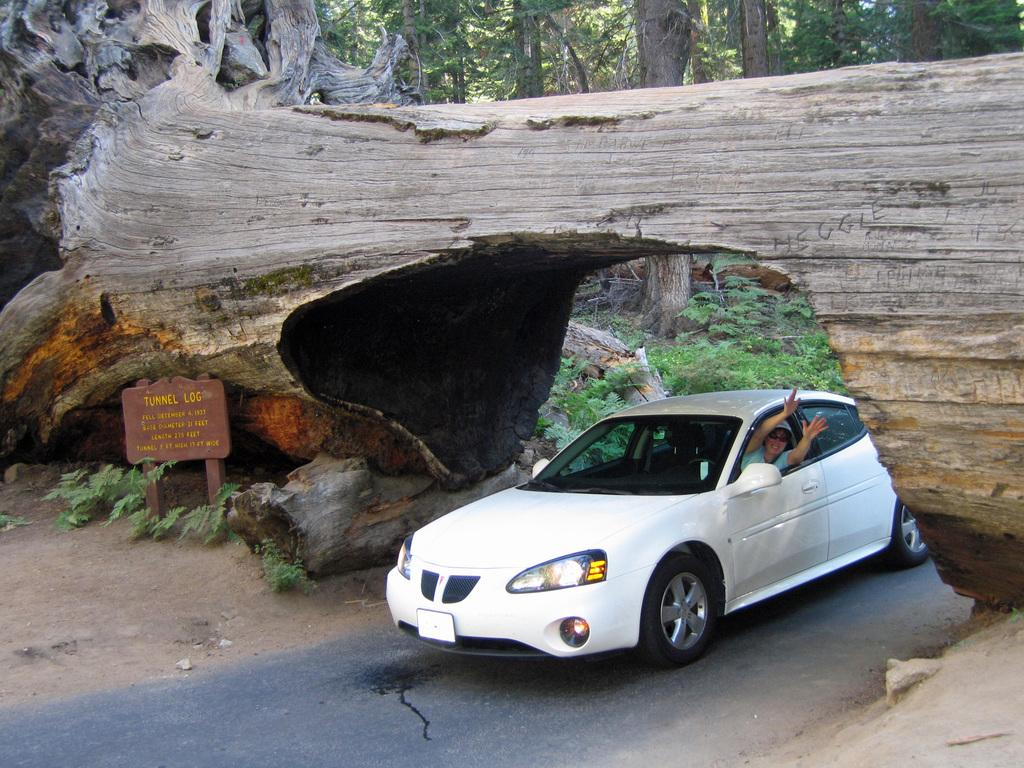What is the main subject of the image? The main subject of the image is a car. Where is the car located in the image? The car is under a tree trunk in the image. Are there any people inside the car? Yes, there are persons in the vehicle. What else can be seen in the image besides the car? There is a signboard, trees, and plants in the image. What type of cakes are being served on the airplane in the image? There is no airplane or cakes present in the image; it features a car under a tree trunk with people inside. What button is being pushed by the creature in the image? There is no creature or button present in the image. 